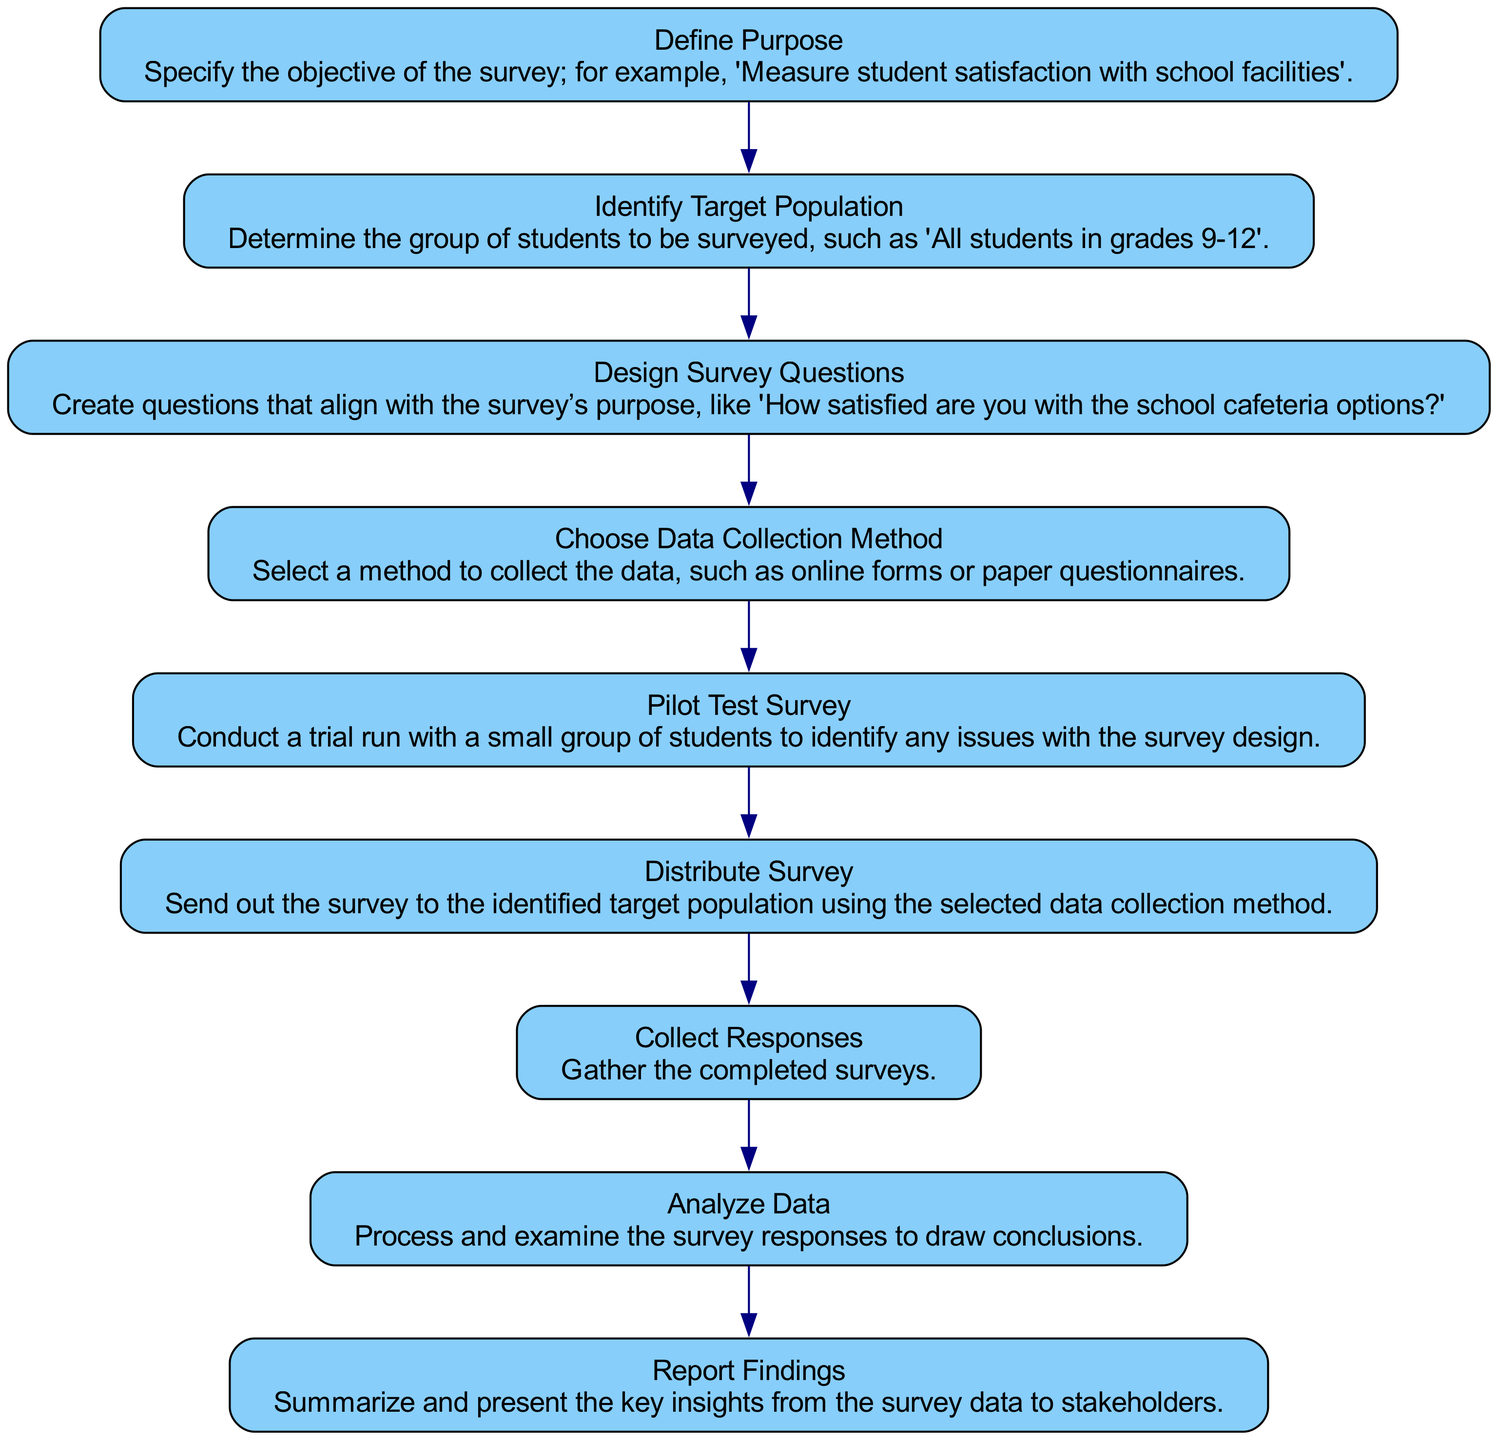What is the first step in the process? The first step in the process, as indicated in the diagram, is to "Define Purpose". This is reflected in the first node of the flow chart, which is sequentially the initial action in the data collection process.
Answer: Define Purpose How many total steps are there in the survey process? Counting all the nodes in the flow chart, there are nine distinct steps total, indicating the complete flow of actions taken in the statistical data collection process.
Answer: 9 What follows after "Pilot Test Survey"? After the "Pilot Test Survey" step, the next step in the sequence is "Distribute Survey". This is determined by tracing the flow from the pilot test node to its subsequent node.
Answer: Distribute Survey Which step involves processing and examining the survey responses? The step that involves processing and examining the survey responses is called "Analyze Data". This is explicitly stated in the corresponding node that focuses on the analysis part of the data collection process.
Answer: Analyze Data What is the purpose of the "Identify Target Population" step? The "Identify Target Population" step serves to determine which specific group of students will be surveyed, as outlined in the description of this node. The goal is to narrow down the focus group for appropriate data collection.
Answer: Determine group In which step is the survey sent out? The survey is sent out during the "Distribute Survey" step. This action is highlighted in the flow chart, indicating the transition to the actual distribution after preparation phases.
Answer: Distribute Survey What happens after collecting responses? After collecting responses, the next step is to "Analyze Data". This progression shows that once the responses are gathered, the focus shifts towards understanding and evaluating the collected data.
Answer: Analyze Data Which step involves trial testing? The step that involves trial testing of the survey is "Pilot Test Survey". This is uniquely defined in the flow chart as a preparatory phase meant to identify any problems before the survey is widely distributed.
Answer: Pilot Test Survey What is the final step outlined in the process? The final step outlined in the process is "Report Findings". This last node indicates the concluding action of summarizing and presenting the insights gained from the survey to relevant stakeholders.
Answer: Report Findings 